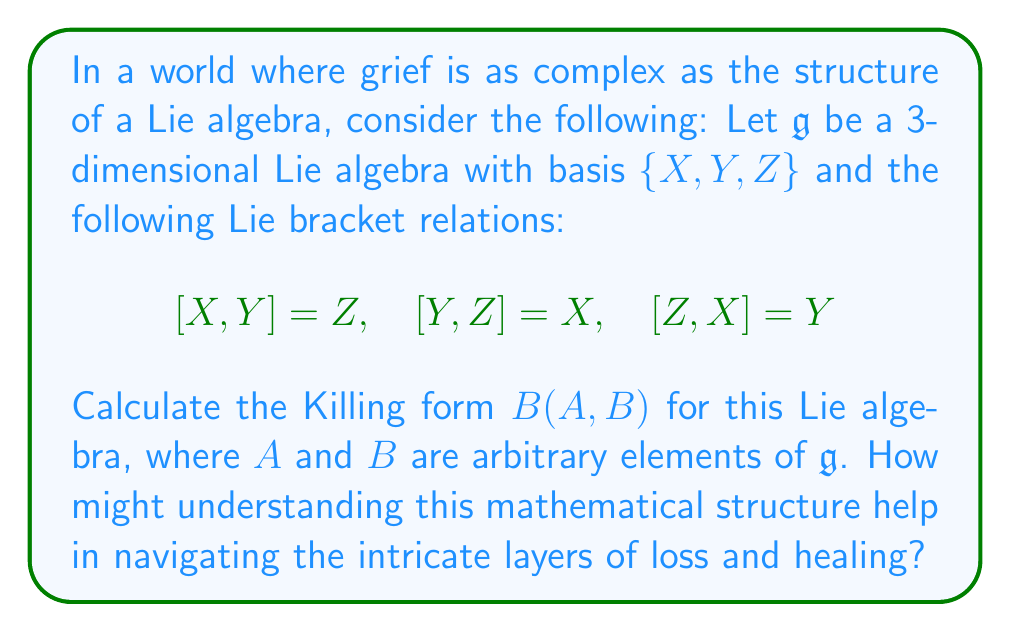Can you answer this question? To calculate the Killing form for this Lie algebra, we'll follow these steps:

1) The Killing form is defined as $B(A,B) = \text{tr}(\text{ad}(A) \circ \text{ad}(B))$, where $\text{ad}$ is the adjoint representation.

2) First, we need to find the matrix representations of $\text{ad}(X)$, $\text{ad}(Y)$, and $\text{ad}(Z)$:

   For $\text{ad}(X)$:
   $$\text{ad}(X)(X) = 0,\quad \text{ad}(X)(Y) = Z,\quad \text{ad}(X)(Z) = -Y$$
   So, $\text{ad}(X) = \begin{pmatrix} 0 & 0 & 0 \\ 0 & 0 & -1 \\ 0 & 1 & 0 \end{pmatrix}$

   Similarly,
   $\text{ad}(Y) = \begin{pmatrix} 0 & 0 & 1 \\ 0 & 0 & 0 \\ -1 & 0 & 0 \end{pmatrix}$
   $\text{ad}(Z) = \begin{pmatrix} 0 & -1 & 0 \\ 1 & 0 & 0 \\ 0 & 0 & 0 \end{pmatrix}$

3) For arbitrary $A = aX + bY + cZ$ and $B = dX + eY + fZ$, we have:
   $$\text{ad}(A) = a\text{ad}(X) + b\text{ad}(Y) + c\text{ad}(Z)$$
   $$\text{ad}(B) = d\text{ad}(X) + e\text{ad}(Y) + f\text{ad}(Z)$$

4) Multiplying these matrices and taking the trace:

   $B(A,B) = \text{tr}(\text{ad}(A) \circ \text{ad}(B))$
            $= \text{tr}((a\text{ad}(X) + b\text{ad}(Y) + c\text{ad}(Z)) \circ (d\text{ad}(X) + e\text{ad}(Y) + f\text{ad}(Z)))$
            $= 2(ad + be + cf)$

5) This result shows that the Killing form is symmetric and bilinear.

Understanding this structure can be metaphorical for grief: like the Killing form reveals the underlying structure of a Lie algebra, working through grief can reveal the deep, interconnected nature of our emotions and memories.
Answer: The Killing form for this Lie algebra is $B(A,B) = 2(ad + be + cf)$, where $A = aX + bY + cZ$ and $B = dX + eY + fZ$ are arbitrary elements of $\mathfrak{g}$. 